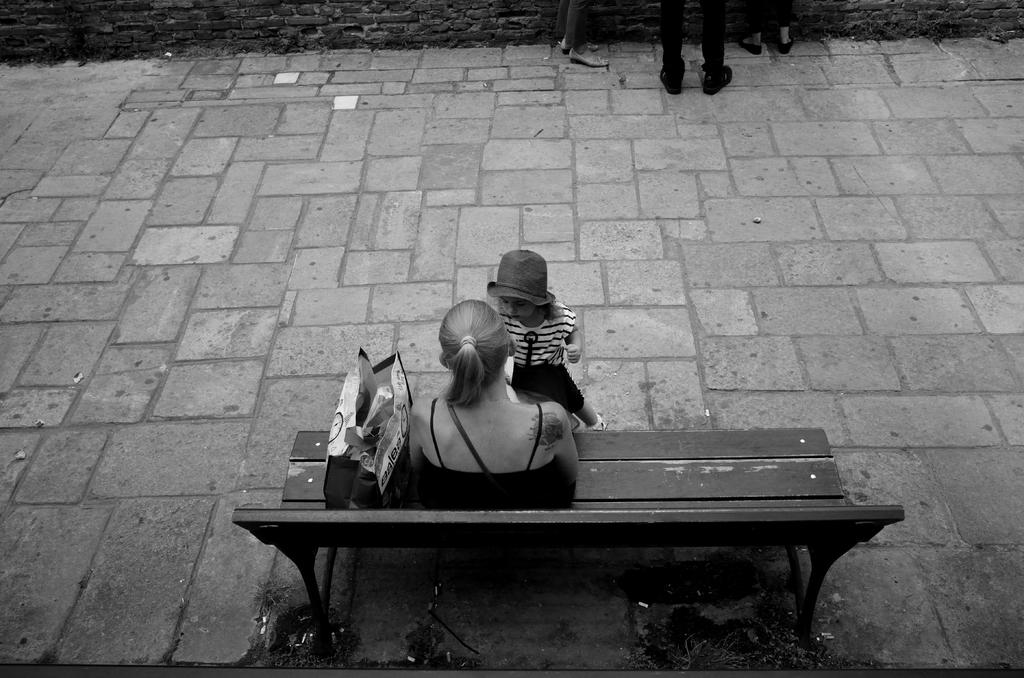What is the color scheme of the image? The image is black and white. What is the woman in the image doing? The woman is sitting on a bench. Who is standing in front of the woman? There is a girl standing in front of the woman. What is placed beside the woman on the woman on the bench? There is a cover kept beside the woman on the bench. What type of meal is being prepared in the prison depicted in the image? There is no prison or meal preparation depicted in the image; it features a woman sitting on a bench with a girl standing in front of her and a cover placed beside her. 